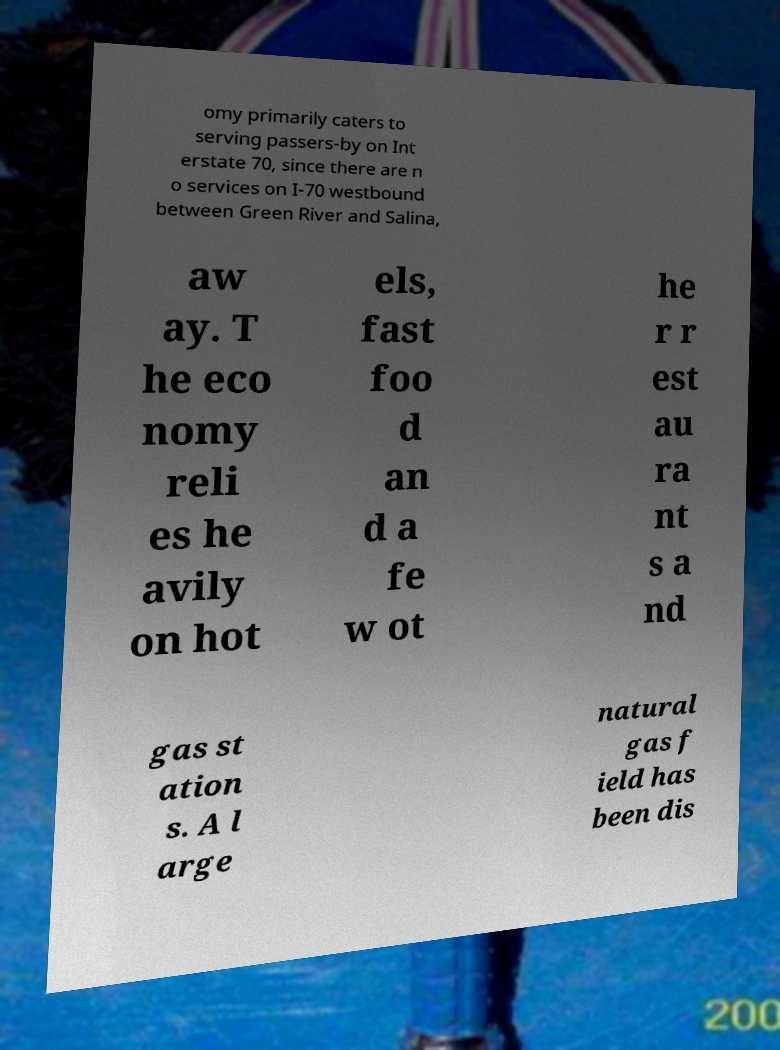Please identify and transcribe the text found in this image. omy primarily caters to serving passers-by on Int erstate 70, since there are n o services on I-70 westbound between Green River and Salina, aw ay. T he eco nomy reli es he avily on hot els, fast foo d an d a fe w ot he r r est au ra nt s a nd gas st ation s. A l arge natural gas f ield has been dis 